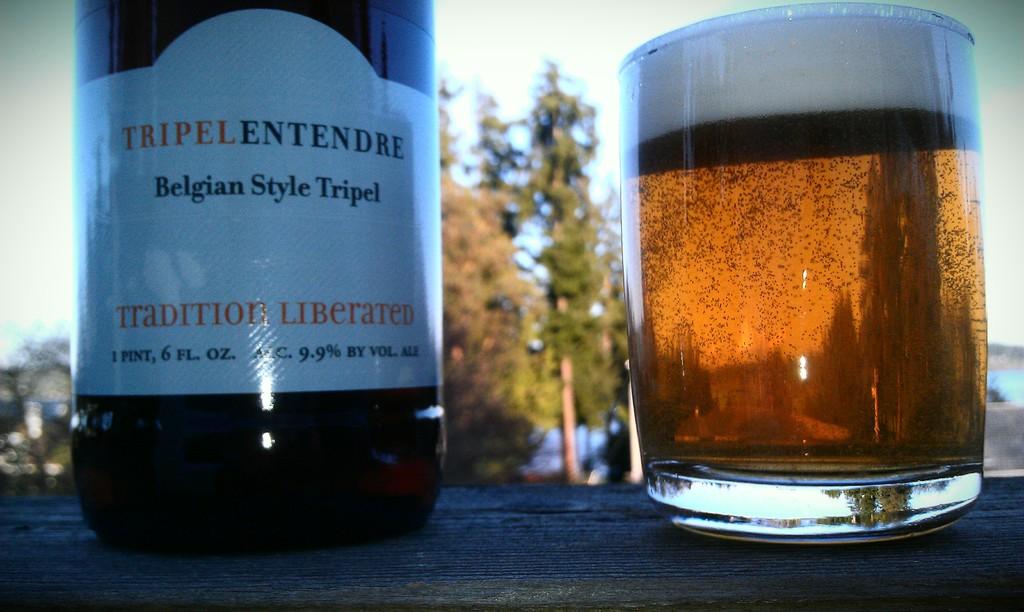What is the alcohol percentage?
Provide a short and direct response. 9.9. 